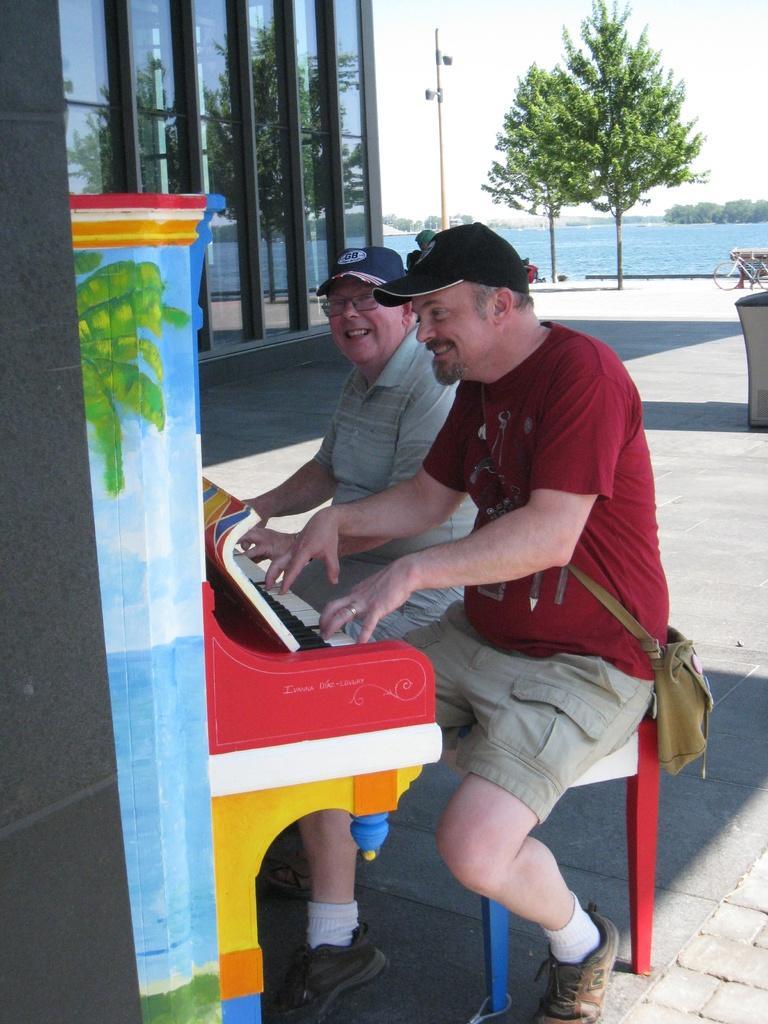Could you give a brief overview of what you see in this image? In this image there are 2 persons sitting in chair ,and playing piano and at the back ground there is building, pole,tree, beach , sky, bicycle. 